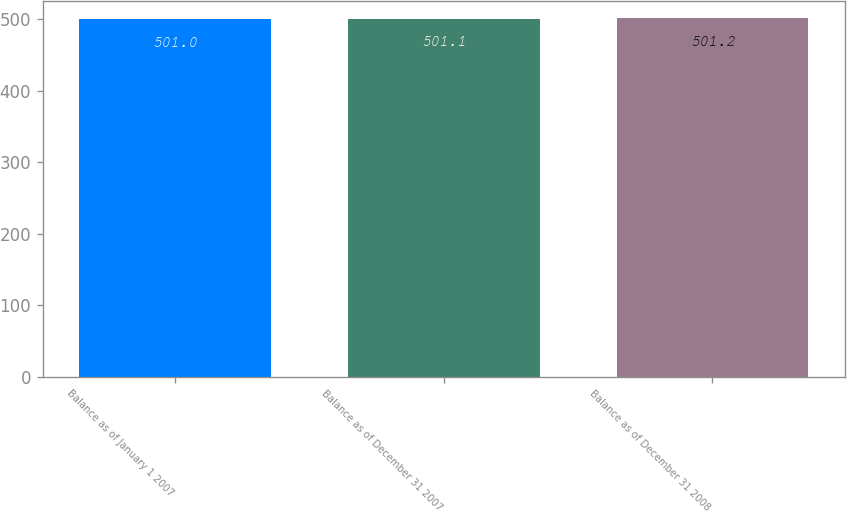<chart> <loc_0><loc_0><loc_500><loc_500><bar_chart><fcel>Balance as of January 1 2007<fcel>Balance as of December 31 2007<fcel>Balance as of December 31 2008<nl><fcel>501<fcel>501.1<fcel>501.2<nl></chart> 